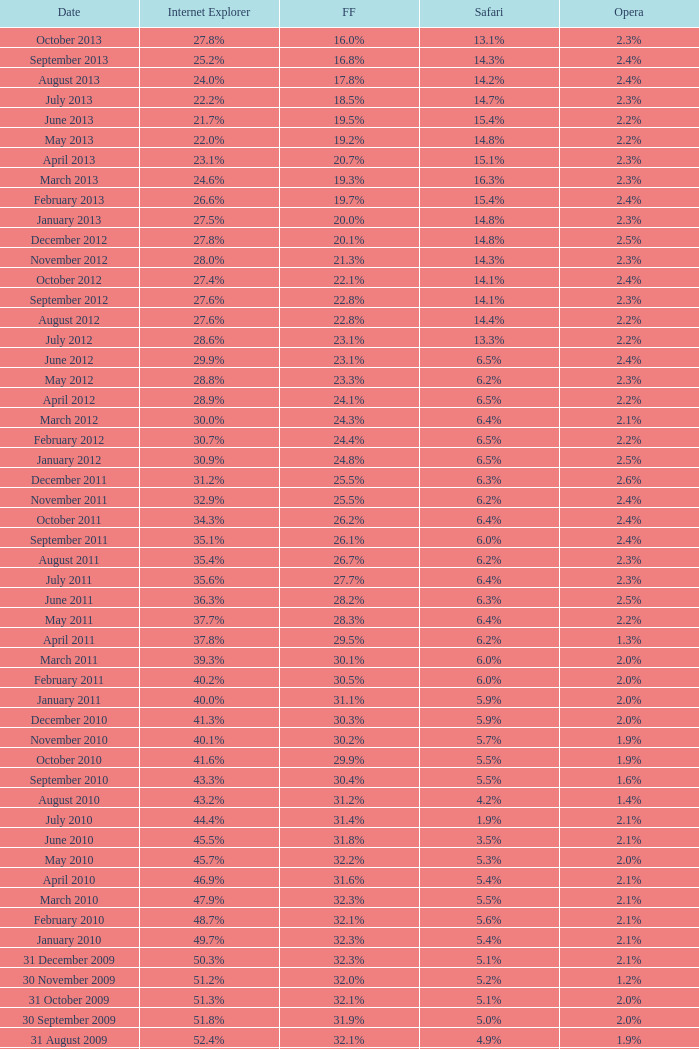0% internet explorer? 19.2%. 